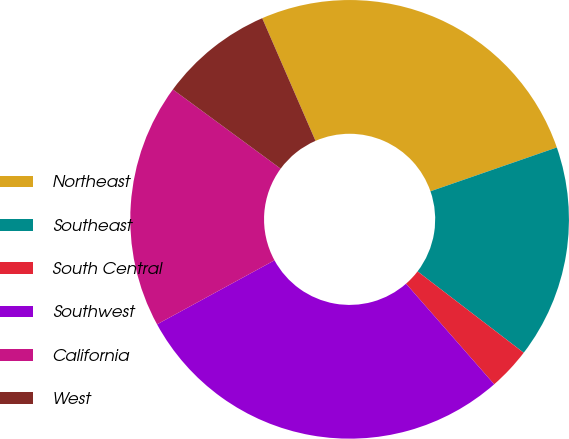Convert chart to OTSL. <chart><loc_0><loc_0><loc_500><loc_500><pie_chart><fcel>Northeast<fcel>Southeast<fcel>South Central<fcel>Southwest<fcel>California<fcel>West<nl><fcel>26.21%<fcel>15.72%<fcel>3.14%<fcel>28.51%<fcel>18.03%<fcel>8.39%<nl></chart> 